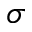Convert formula to latex. <formula><loc_0><loc_0><loc_500><loc_500>\sigma</formula> 